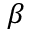Convert formula to latex. <formula><loc_0><loc_0><loc_500><loc_500>\beta</formula> 